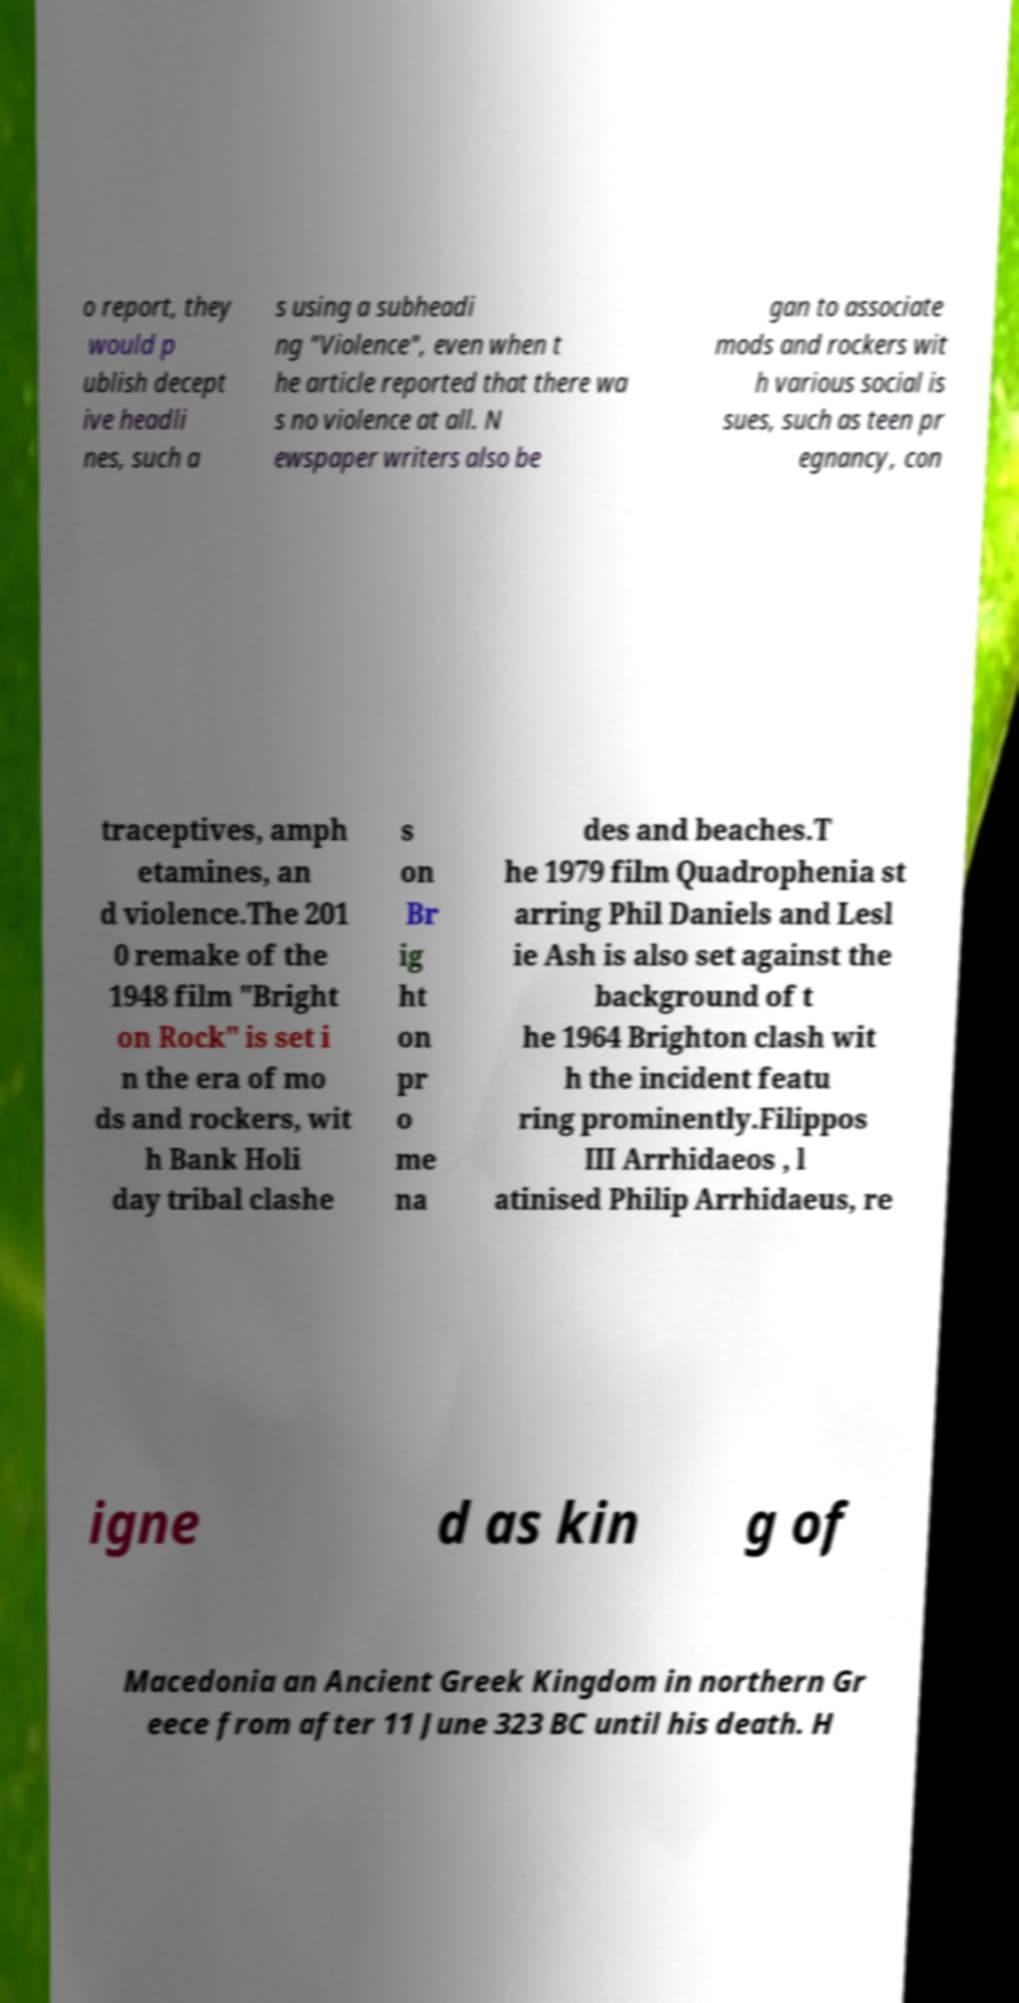Please read and relay the text visible in this image. What does it say? o report, they would p ublish decept ive headli nes, such a s using a subheadi ng "Violence", even when t he article reported that there wa s no violence at all. N ewspaper writers also be gan to associate mods and rockers wit h various social is sues, such as teen pr egnancy, con traceptives, amph etamines, an d violence.The 201 0 remake of the 1948 film "Bright on Rock" is set i n the era of mo ds and rockers, wit h Bank Holi day tribal clashe s on Br ig ht on pr o me na des and beaches.T he 1979 film Quadrophenia st arring Phil Daniels and Lesl ie Ash is also set against the background of t he 1964 Brighton clash wit h the incident featu ring prominently.Filippos III Arrhidaeos , l atinised Philip Arrhidaeus, re igne d as kin g of Macedonia an Ancient Greek Kingdom in northern Gr eece from after 11 June 323 BC until his death. H 